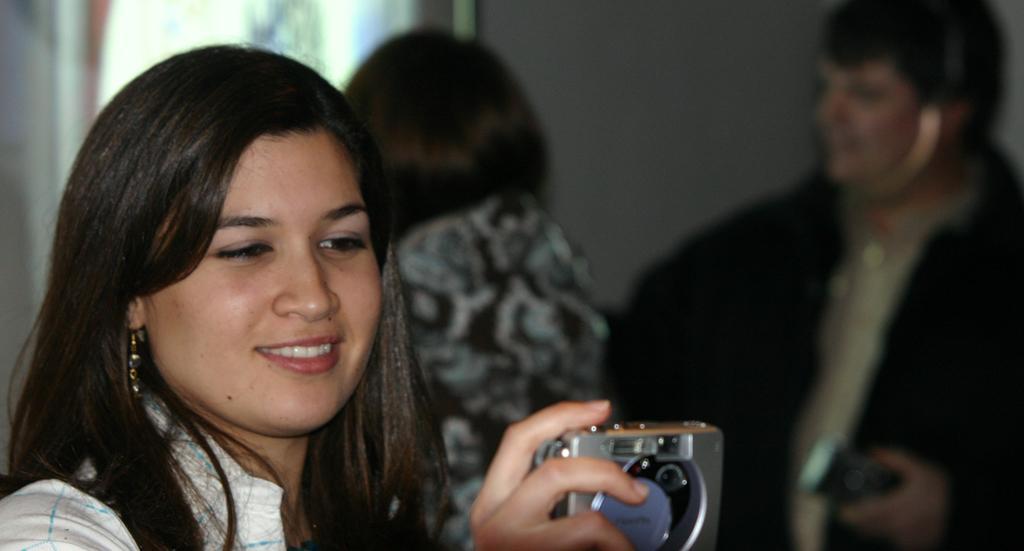Can you describe this image briefly? This picture shows a woman smiling and taking a picture with her digital camera in her hand. In the background there are some people standing and talking. We can observe a wall here. 